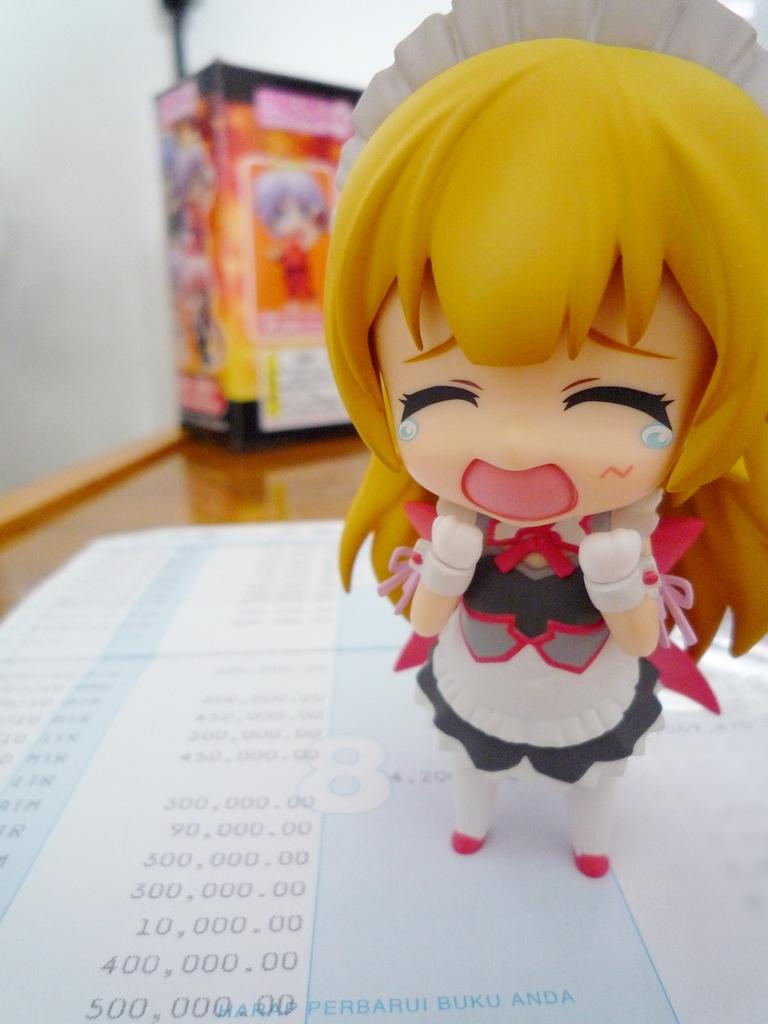What is the main subject in the image? There is a doll in the image. What else can be seen on the table in the image? There is a paper on a table in the image. What is located in the background of the image? There is a box and a wall in the background of the image. What type of class is being taught in the image? There is no class or teaching activity depicted in the image. Can you see a scarecrow in the image? No, there is no scarecrow present in the image. 